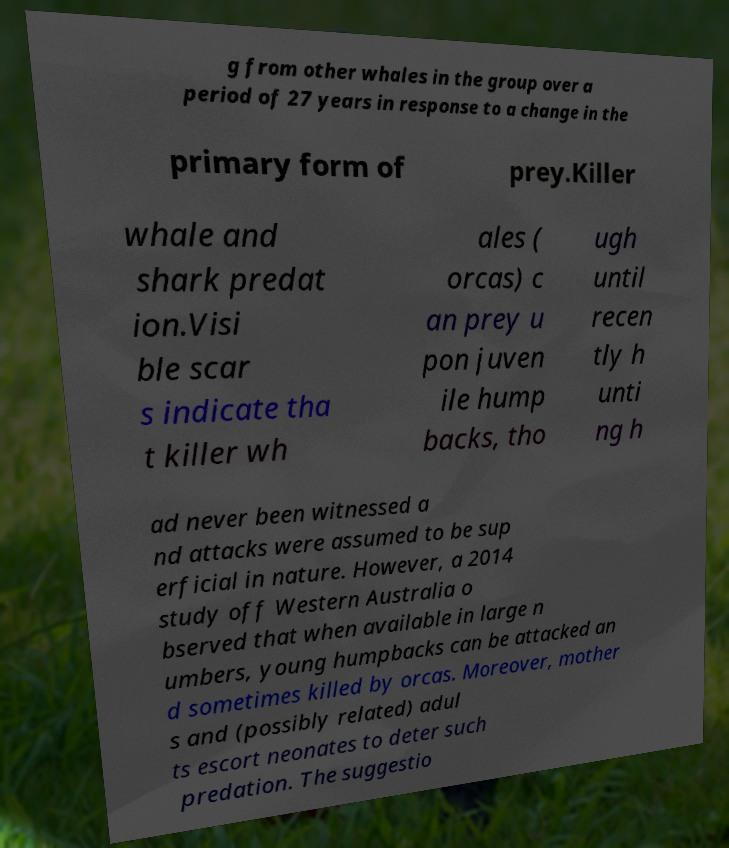What messages or text are displayed in this image? I need them in a readable, typed format. g from other whales in the group over a period of 27 years in response to a change in the primary form of prey.Killer whale and shark predat ion.Visi ble scar s indicate tha t killer wh ales ( orcas) c an prey u pon juven ile hump backs, tho ugh until recen tly h unti ng h ad never been witnessed a nd attacks were assumed to be sup erficial in nature. However, a 2014 study off Western Australia o bserved that when available in large n umbers, young humpbacks can be attacked an d sometimes killed by orcas. Moreover, mother s and (possibly related) adul ts escort neonates to deter such predation. The suggestio 